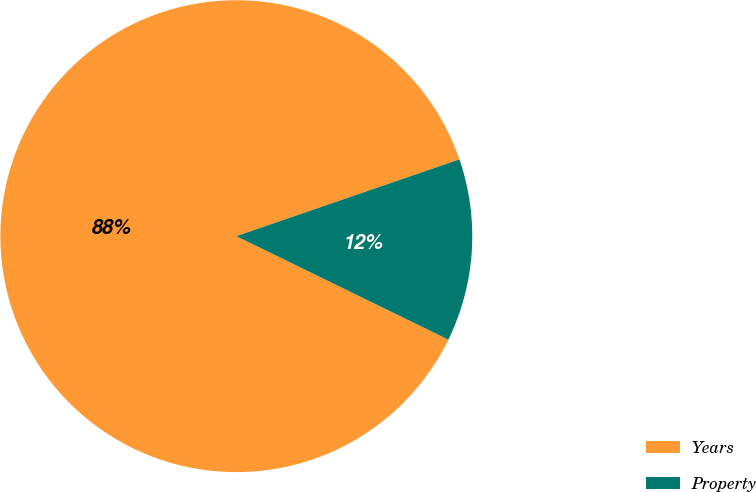Convert chart. <chart><loc_0><loc_0><loc_500><loc_500><pie_chart><fcel>Years<fcel>Property<nl><fcel>87.5%<fcel>12.5%<nl></chart> 